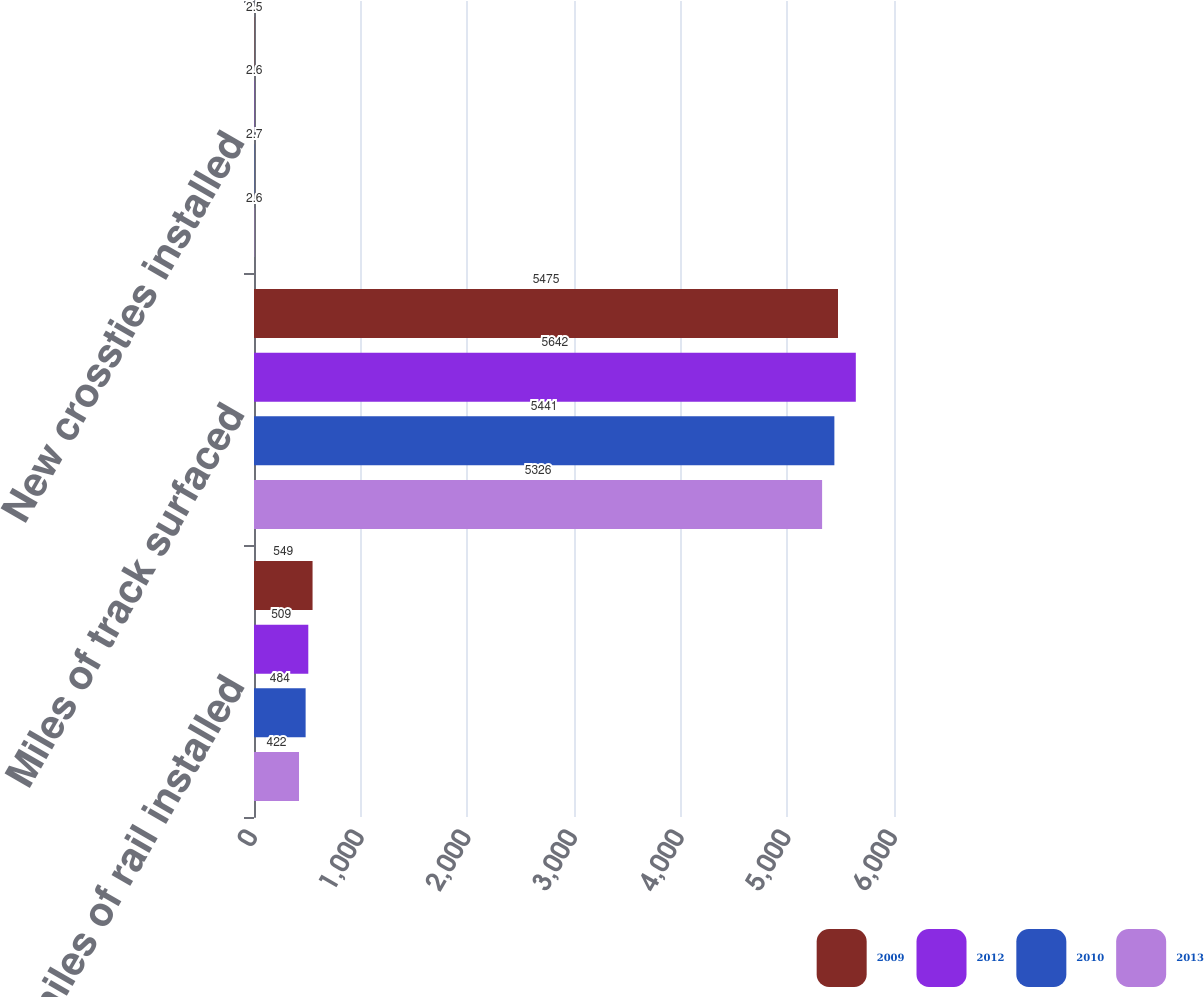<chart> <loc_0><loc_0><loc_500><loc_500><stacked_bar_chart><ecel><fcel>Track miles of rail installed<fcel>Miles of track surfaced<fcel>New crossties installed<nl><fcel>2009<fcel>549<fcel>5475<fcel>2.5<nl><fcel>2012<fcel>509<fcel>5642<fcel>2.6<nl><fcel>2010<fcel>484<fcel>5441<fcel>2.7<nl><fcel>2013<fcel>422<fcel>5326<fcel>2.6<nl></chart> 